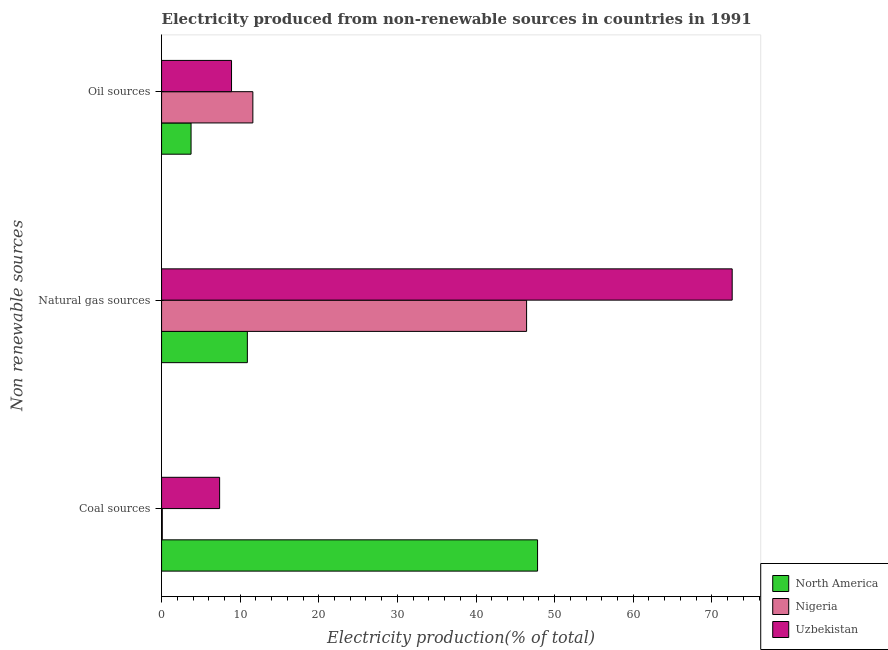How many groups of bars are there?
Offer a terse response. 3. Are the number of bars on each tick of the Y-axis equal?
Provide a short and direct response. Yes. What is the label of the 3rd group of bars from the top?
Provide a short and direct response. Coal sources. What is the percentage of electricity produced by oil sources in North America?
Keep it short and to the point. 3.75. Across all countries, what is the maximum percentage of electricity produced by coal?
Keep it short and to the point. 47.83. Across all countries, what is the minimum percentage of electricity produced by coal?
Offer a very short reply. 0.09. In which country was the percentage of electricity produced by natural gas maximum?
Your answer should be very brief. Uzbekistan. What is the total percentage of electricity produced by coal in the graph?
Give a very brief answer. 55.3. What is the difference between the percentage of electricity produced by coal in North America and that in Nigeria?
Your answer should be compact. 47.73. What is the difference between the percentage of electricity produced by natural gas in Uzbekistan and the percentage of electricity produced by coal in Nigeria?
Provide a short and direct response. 72.49. What is the average percentage of electricity produced by coal per country?
Offer a terse response. 18.43. What is the difference between the percentage of electricity produced by oil sources and percentage of electricity produced by natural gas in Nigeria?
Provide a short and direct response. -34.82. What is the ratio of the percentage of electricity produced by oil sources in North America to that in Uzbekistan?
Give a very brief answer. 0.42. Is the percentage of electricity produced by coal in Uzbekistan less than that in Nigeria?
Your answer should be very brief. No. What is the difference between the highest and the second highest percentage of electricity produced by natural gas?
Provide a short and direct response. 26.15. What is the difference between the highest and the lowest percentage of electricity produced by coal?
Offer a terse response. 47.73. In how many countries, is the percentage of electricity produced by oil sources greater than the average percentage of electricity produced by oil sources taken over all countries?
Offer a terse response. 2. What does the 1st bar from the top in Oil sources represents?
Ensure brevity in your answer.  Uzbekistan. What does the 3rd bar from the bottom in Coal sources represents?
Your answer should be compact. Uzbekistan. Is it the case that in every country, the sum of the percentage of electricity produced by coal and percentage of electricity produced by natural gas is greater than the percentage of electricity produced by oil sources?
Offer a terse response. Yes. Are all the bars in the graph horizontal?
Provide a short and direct response. Yes. Does the graph contain any zero values?
Ensure brevity in your answer.  No. How are the legend labels stacked?
Your answer should be compact. Vertical. What is the title of the graph?
Offer a very short reply. Electricity produced from non-renewable sources in countries in 1991. What is the label or title of the Y-axis?
Keep it short and to the point. Non renewable sources. What is the Electricity production(% of total) of North America in Coal sources?
Offer a very short reply. 47.83. What is the Electricity production(% of total) in Nigeria in Coal sources?
Give a very brief answer. 0.09. What is the Electricity production(% of total) in Uzbekistan in Coal sources?
Provide a short and direct response. 7.38. What is the Electricity production(% of total) in North America in Natural gas sources?
Offer a terse response. 10.91. What is the Electricity production(% of total) of Nigeria in Natural gas sources?
Offer a very short reply. 46.43. What is the Electricity production(% of total) in Uzbekistan in Natural gas sources?
Provide a succinct answer. 72.58. What is the Electricity production(% of total) in North America in Oil sources?
Provide a short and direct response. 3.75. What is the Electricity production(% of total) in Nigeria in Oil sources?
Keep it short and to the point. 11.61. What is the Electricity production(% of total) of Uzbekistan in Oil sources?
Ensure brevity in your answer.  8.9. Across all Non renewable sources, what is the maximum Electricity production(% of total) in North America?
Your answer should be compact. 47.83. Across all Non renewable sources, what is the maximum Electricity production(% of total) of Nigeria?
Give a very brief answer. 46.43. Across all Non renewable sources, what is the maximum Electricity production(% of total) in Uzbekistan?
Your answer should be compact. 72.58. Across all Non renewable sources, what is the minimum Electricity production(% of total) in North America?
Your response must be concise. 3.75. Across all Non renewable sources, what is the minimum Electricity production(% of total) in Nigeria?
Keep it short and to the point. 0.09. Across all Non renewable sources, what is the minimum Electricity production(% of total) of Uzbekistan?
Your answer should be very brief. 7.38. What is the total Electricity production(% of total) of North America in the graph?
Your response must be concise. 62.49. What is the total Electricity production(% of total) in Nigeria in the graph?
Keep it short and to the point. 58.14. What is the total Electricity production(% of total) of Uzbekistan in the graph?
Offer a terse response. 88.87. What is the difference between the Electricity production(% of total) of North America in Coal sources and that in Natural gas sources?
Give a very brief answer. 36.91. What is the difference between the Electricity production(% of total) of Nigeria in Coal sources and that in Natural gas sources?
Offer a very short reply. -46.34. What is the difference between the Electricity production(% of total) in Uzbekistan in Coal sources and that in Natural gas sources?
Give a very brief answer. -65.2. What is the difference between the Electricity production(% of total) of North America in Coal sources and that in Oil sources?
Ensure brevity in your answer.  44.07. What is the difference between the Electricity production(% of total) in Nigeria in Coal sources and that in Oil sources?
Your answer should be compact. -11.52. What is the difference between the Electricity production(% of total) in Uzbekistan in Coal sources and that in Oil sources?
Provide a succinct answer. -1.51. What is the difference between the Electricity production(% of total) of North America in Natural gas sources and that in Oil sources?
Make the answer very short. 7.16. What is the difference between the Electricity production(% of total) of Nigeria in Natural gas sources and that in Oil sources?
Offer a very short reply. 34.82. What is the difference between the Electricity production(% of total) in Uzbekistan in Natural gas sources and that in Oil sources?
Keep it short and to the point. 63.68. What is the difference between the Electricity production(% of total) in North America in Coal sources and the Electricity production(% of total) in Nigeria in Natural gas sources?
Your response must be concise. 1.39. What is the difference between the Electricity production(% of total) of North America in Coal sources and the Electricity production(% of total) of Uzbekistan in Natural gas sources?
Give a very brief answer. -24.76. What is the difference between the Electricity production(% of total) of Nigeria in Coal sources and the Electricity production(% of total) of Uzbekistan in Natural gas sources?
Ensure brevity in your answer.  -72.49. What is the difference between the Electricity production(% of total) of North America in Coal sources and the Electricity production(% of total) of Nigeria in Oil sources?
Offer a terse response. 36.21. What is the difference between the Electricity production(% of total) of North America in Coal sources and the Electricity production(% of total) of Uzbekistan in Oil sources?
Your answer should be very brief. 38.93. What is the difference between the Electricity production(% of total) of Nigeria in Coal sources and the Electricity production(% of total) of Uzbekistan in Oil sources?
Provide a succinct answer. -8.81. What is the difference between the Electricity production(% of total) of North America in Natural gas sources and the Electricity production(% of total) of Nigeria in Oil sources?
Your answer should be compact. -0.7. What is the difference between the Electricity production(% of total) in North America in Natural gas sources and the Electricity production(% of total) in Uzbekistan in Oil sources?
Make the answer very short. 2.01. What is the difference between the Electricity production(% of total) in Nigeria in Natural gas sources and the Electricity production(% of total) in Uzbekistan in Oil sources?
Offer a very short reply. 37.53. What is the average Electricity production(% of total) in North America per Non renewable sources?
Offer a very short reply. 20.83. What is the average Electricity production(% of total) of Nigeria per Non renewable sources?
Ensure brevity in your answer.  19.38. What is the average Electricity production(% of total) of Uzbekistan per Non renewable sources?
Ensure brevity in your answer.  29.62. What is the difference between the Electricity production(% of total) in North America and Electricity production(% of total) in Nigeria in Coal sources?
Your response must be concise. 47.73. What is the difference between the Electricity production(% of total) of North America and Electricity production(% of total) of Uzbekistan in Coal sources?
Offer a terse response. 40.44. What is the difference between the Electricity production(% of total) of Nigeria and Electricity production(% of total) of Uzbekistan in Coal sources?
Give a very brief answer. -7.29. What is the difference between the Electricity production(% of total) of North America and Electricity production(% of total) of Nigeria in Natural gas sources?
Your answer should be compact. -35.52. What is the difference between the Electricity production(% of total) of North America and Electricity production(% of total) of Uzbekistan in Natural gas sources?
Provide a short and direct response. -61.67. What is the difference between the Electricity production(% of total) in Nigeria and Electricity production(% of total) in Uzbekistan in Natural gas sources?
Offer a terse response. -26.15. What is the difference between the Electricity production(% of total) of North America and Electricity production(% of total) of Nigeria in Oil sources?
Provide a short and direct response. -7.86. What is the difference between the Electricity production(% of total) of North America and Electricity production(% of total) of Uzbekistan in Oil sources?
Offer a very short reply. -5.15. What is the difference between the Electricity production(% of total) of Nigeria and Electricity production(% of total) of Uzbekistan in Oil sources?
Your answer should be very brief. 2.71. What is the ratio of the Electricity production(% of total) of North America in Coal sources to that in Natural gas sources?
Make the answer very short. 4.38. What is the ratio of the Electricity production(% of total) of Nigeria in Coal sources to that in Natural gas sources?
Ensure brevity in your answer.  0. What is the ratio of the Electricity production(% of total) of Uzbekistan in Coal sources to that in Natural gas sources?
Offer a terse response. 0.1. What is the ratio of the Electricity production(% of total) of North America in Coal sources to that in Oil sources?
Provide a succinct answer. 12.75. What is the ratio of the Electricity production(% of total) in Nigeria in Coal sources to that in Oil sources?
Provide a succinct answer. 0.01. What is the ratio of the Electricity production(% of total) of Uzbekistan in Coal sources to that in Oil sources?
Ensure brevity in your answer.  0.83. What is the ratio of the Electricity production(% of total) of North America in Natural gas sources to that in Oil sources?
Your answer should be compact. 2.91. What is the ratio of the Electricity production(% of total) in Nigeria in Natural gas sources to that in Oil sources?
Keep it short and to the point. 4. What is the ratio of the Electricity production(% of total) of Uzbekistan in Natural gas sources to that in Oil sources?
Give a very brief answer. 8.16. What is the difference between the highest and the second highest Electricity production(% of total) of North America?
Make the answer very short. 36.91. What is the difference between the highest and the second highest Electricity production(% of total) of Nigeria?
Ensure brevity in your answer.  34.82. What is the difference between the highest and the second highest Electricity production(% of total) of Uzbekistan?
Your response must be concise. 63.68. What is the difference between the highest and the lowest Electricity production(% of total) in North America?
Keep it short and to the point. 44.07. What is the difference between the highest and the lowest Electricity production(% of total) in Nigeria?
Your response must be concise. 46.34. What is the difference between the highest and the lowest Electricity production(% of total) in Uzbekistan?
Your response must be concise. 65.2. 